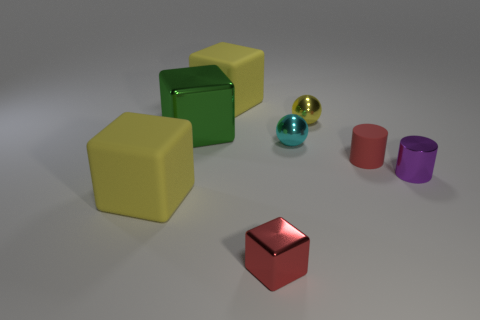Subtract all large green cubes. How many cubes are left? 3 Subtract all green blocks. How many blocks are left? 3 Add 1 purple things. How many objects exist? 9 Subtract 3 blocks. How many blocks are left? 1 Subtract all cylinders. How many objects are left? 6 Subtract all blue cylinders. How many yellow cubes are left? 2 Subtract all red cubes. Subtract all purple cylinders. How many cubes are left? 3 Subtract all big matte things. Subtract all small red metallic cubes. How many objects are left? 5 Add 8 tiny spheres. How many tiny spheres are left? 10 Add 5 brown cylinders. How many brown cylinders exist? 5 